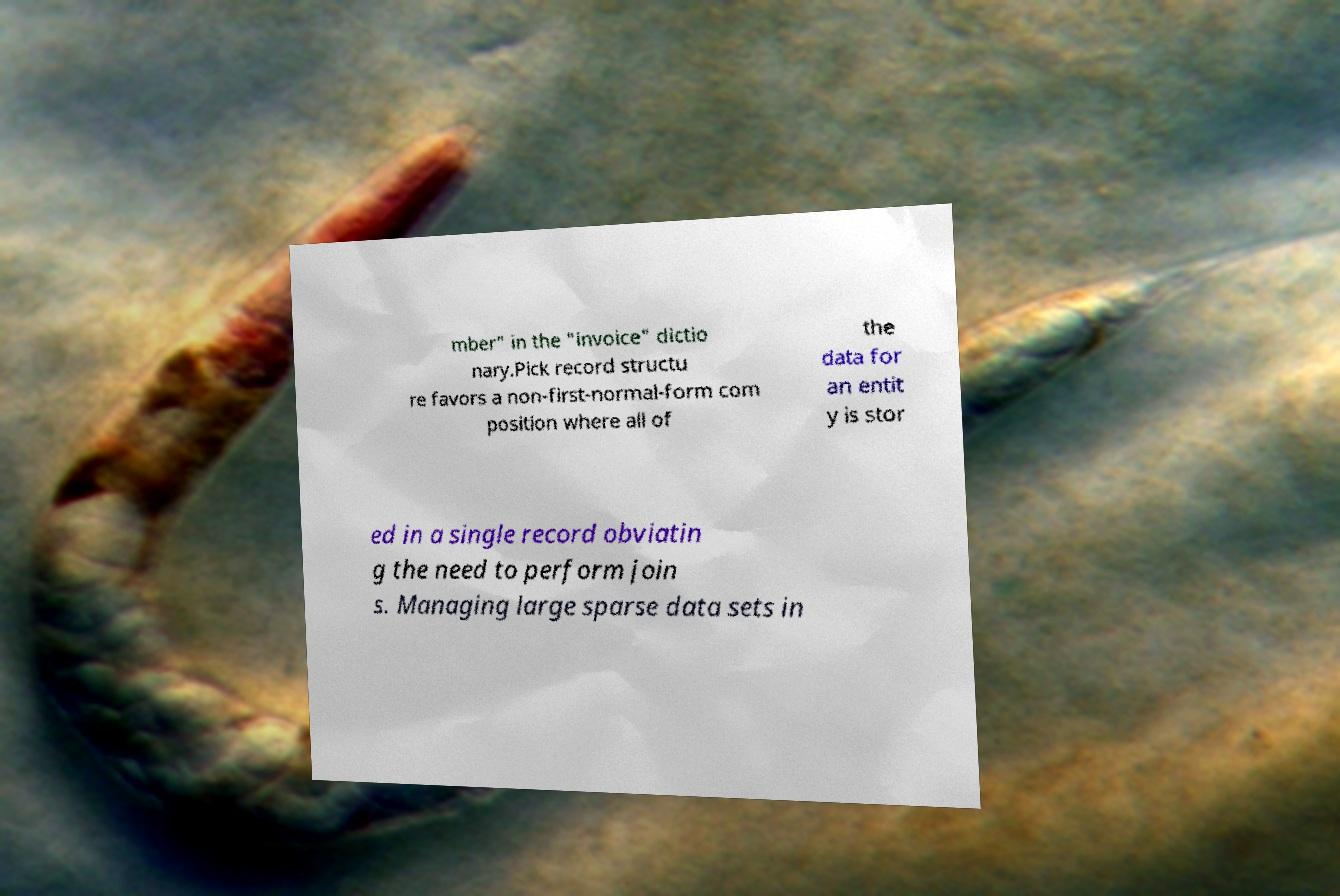There's text embedded in this image that I need extracted. Can you transcribe it verbatim? mber" in the "invoice" dictio nary.Pick record structu re favors a non-first-normal-form com position where all of the data for an entit y is stor ed in a single record obviatin g the need to perform join s. Managing large sparse data sets in 